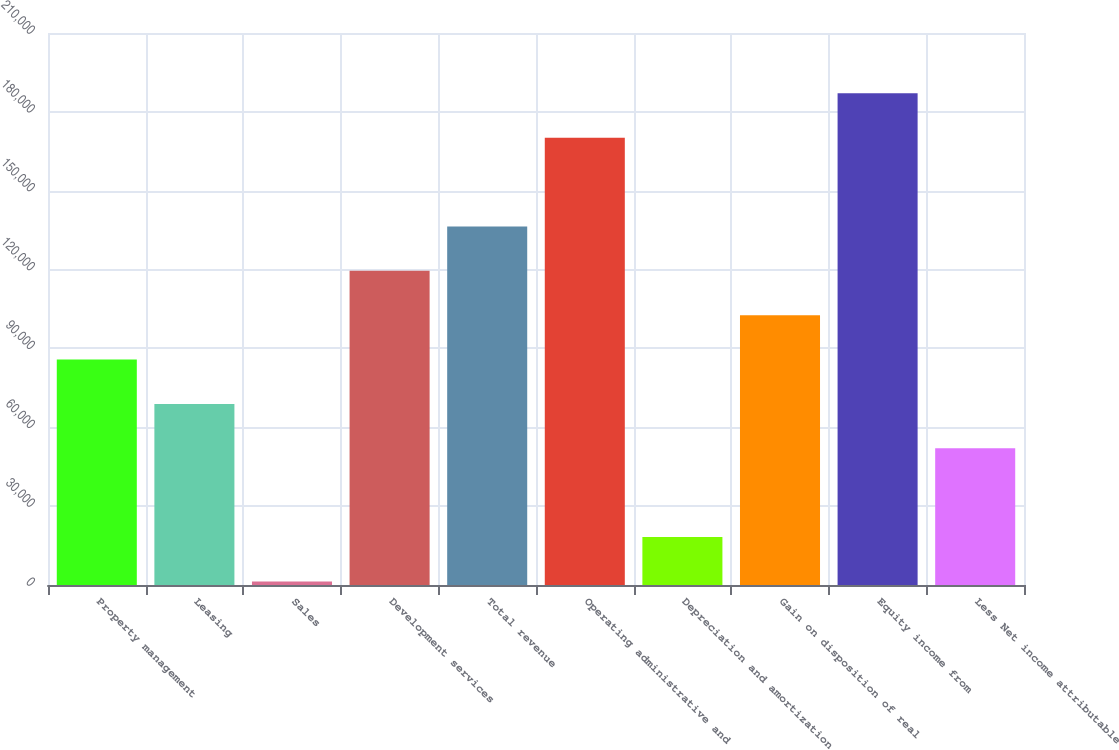<chart> <loc_0><loc_0><loc_500><loc_500><bar_chart><fcel>Property management<fcel>Leasing<fcel>Sales<fcel>Development services<fcel>Total revenue<fcel>Operating administrative and<fcel>Depreciation and amortization<fcel>Gain on disposition of real<fcel>Equity income from<fcel>Less Net income attributable<nl><fcel>85754.5<fcel>68870.2<fcel>1333<fcel>119523<fcel>136407<fcel>170176<fcel>18217.3<fcel>102639<fcel>187060<fcel>51985.9<nl></chart> 